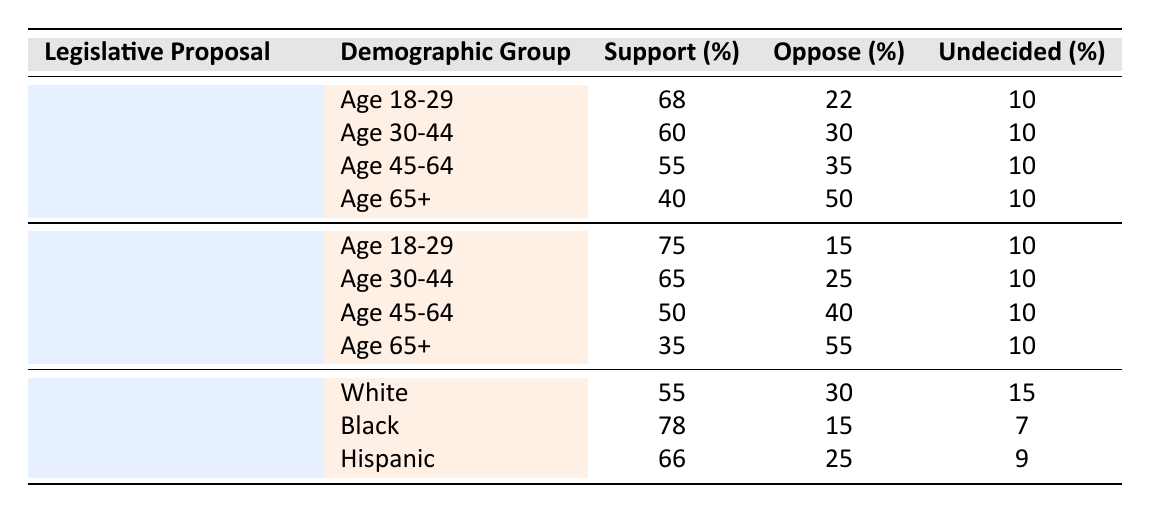What is the support percentage for "Medicare for All" among the demographic group "Age 45-64"? The table lists support percentages for each demographic group under the "Medicare for All" proposal. For "Age 45-64," the support percentage is directly stated as 55%.
Answer: 55% What percentage of the demographic group "Age 30-44" opposes the "Green New Deal"? In the table, the "Green New Deal" shows the opposition percentage for "Age 30-44" as 25%. This information can be found in the row pertaining to "Age 30-44" under the "Green New Deal" section.
Answer: 25% For which demographic group is support for "Criminal Justice Reform" highest? By looking at the support percentages for "Criminal Justice Reform," we see that the "Black" demographic group has the highest support at 78%. This is greater than the support percentages for "White" and "Hispanic" groups, which are 55% and 66%, respectively.
Answer: Black What is the average support percentage for "Medicare for All" across all age groups listed? The support percentages for "Medicare for All" across the age groups are 68, 60, 55, and 40. To find the average, first sum them: 68 + 60 + 55 + 40 = 223. Then, divide by the number of groups: 223 / 4 = 55.75. Thus, the average support percentage is 55.75%.
Answer: 55.75% Is support for the "Green New Deal" among "Age 65+" greater than the support for "Medicare for All" in the same age group? The support percentage for "Green New Deal" among "Age 65+" is 35%, while for "Medicare for All," it is 40%. Since 35 is less than 40, we conclude that support for the "Green New Deal" is not greater.
Answer: No What is the total percentage of opposition to "Criminal Justice Reform" from the demographic groups listed? The opposition percentages for the three demographic groups ("White," "Black," and "Hispanic") are 30%, 15%, and 25%, respectively. To find the total opposition, add these percentages: 30 + 15 + 25 = 70%.
Answer: 70% Which legislative proposal has the lowest support percentage among the "Age 65+" demographic? Upon examining the support percentages for the "Age 65+" demographic, "Green New Deal" has a support percentage of 35%, which is lower than 40% for "Medicare for All" and 40% for "Criminal Justice Reform." Therefore, "Green New Deal" has the lowest support percentage among this age group.
Answer: Green New Deal How many demographic groups are listed for the "Green New Deal" proposal? The table provides support data for the "Green New Deal" across four age groups: "Age 18-29," "Age 30-44," "Age 45-64," and "Age 65+." Counting these, we find there are four distinct demographic groups.
Answer: 4 